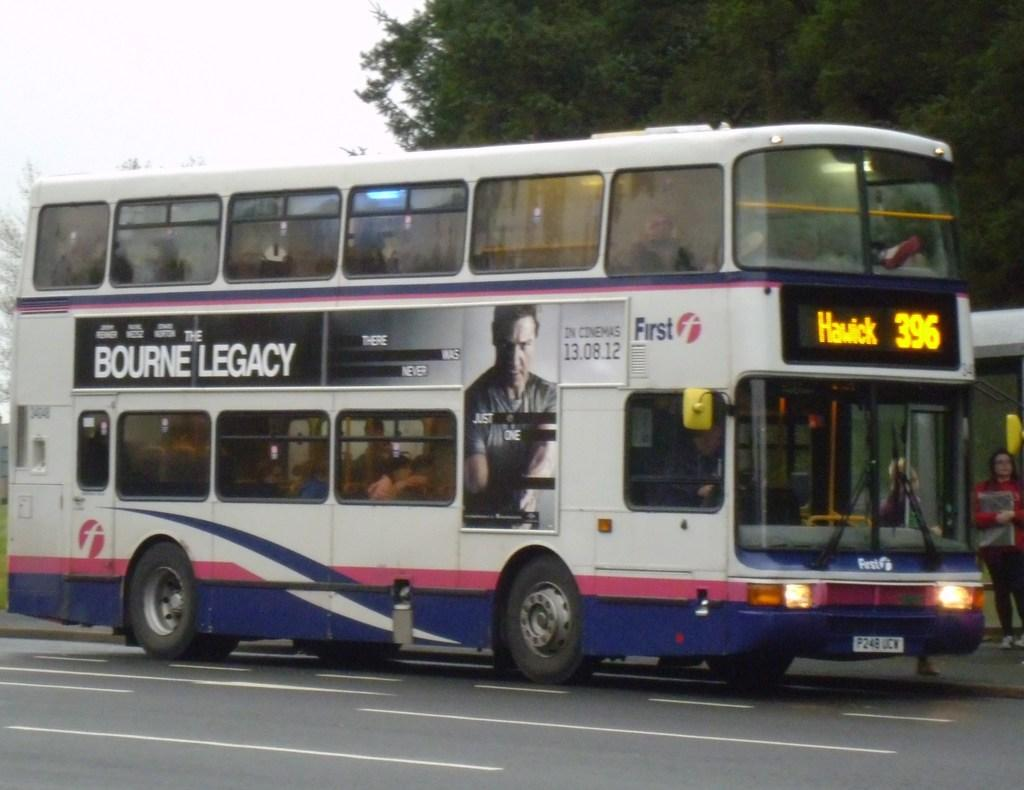<image>
Create a compact narrative representing the image presented. bus number 396 heading to hawick with an ad for bourne legacy on the side of it 